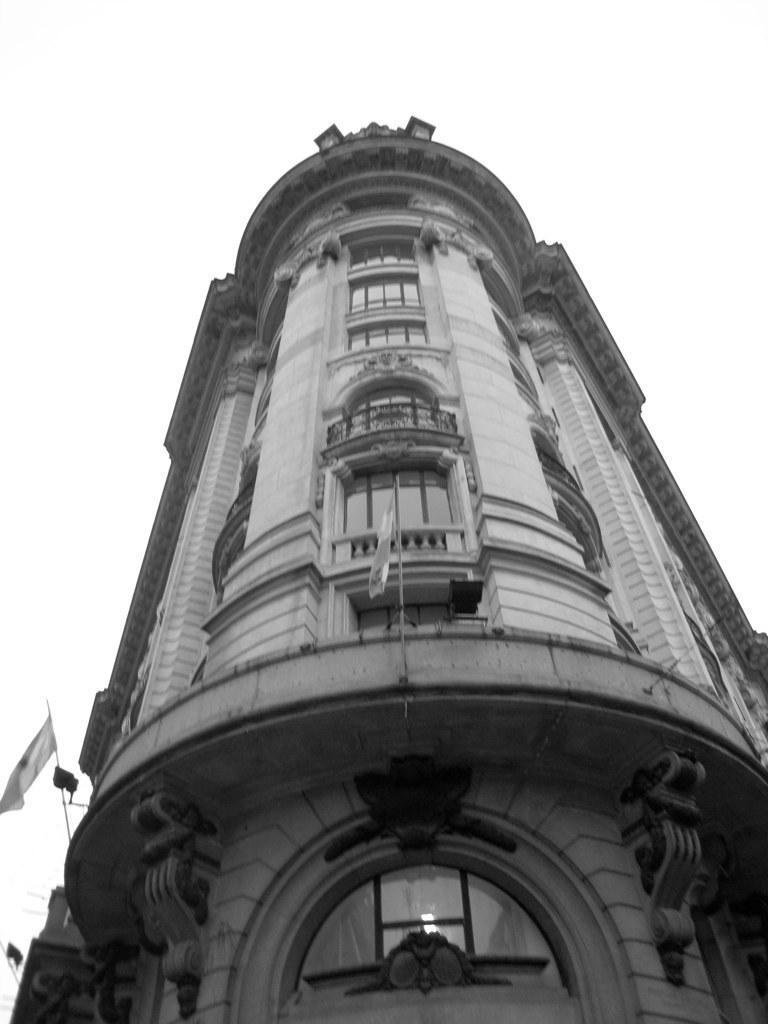Can you describe this image briefly? In this image in the center there is a building and there are some flags, in the background there is sky. 